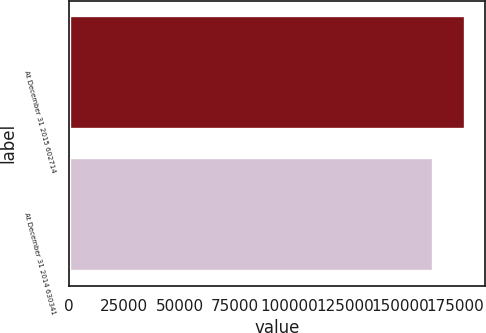<chart> <loc_0><loc_0><loc_500><loc_500><bar_chart><fcel>At December 31 2015 602714<fcel>At December 31 2014 630341<nl><fcel>179708<fcel>165147<nl></chart> 